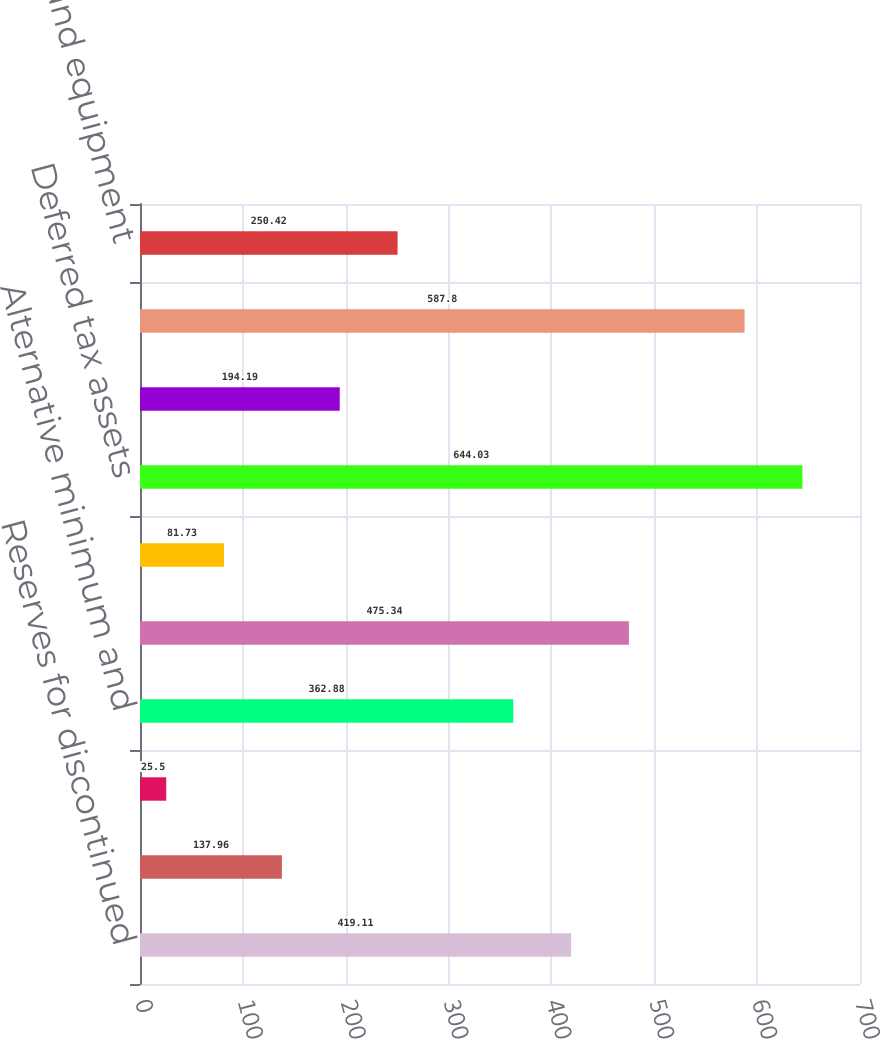<chart> <loc_0><loc_0><loc_500><loc_500><bar_chart><fcel>Reserves for discontinued<fcel>Accrued pension and other<fcel>Other reserves<fcel>Alternative minimum and<fcel>Net operating loss<fcel>Other<fcel>Deferred tax assets<fcel>Valuation allowance<fcel>Deferred tax assets net of<fcel>Property plant and equipment<nl><fcel>419.11<fcel>137.96<fcel>25.5<fcel>362.88<fcel>475.34<fcel>81.73<fcel>644.03<fcel>194.19<fcel>587.8<fcel>250.42<nl></chart> 